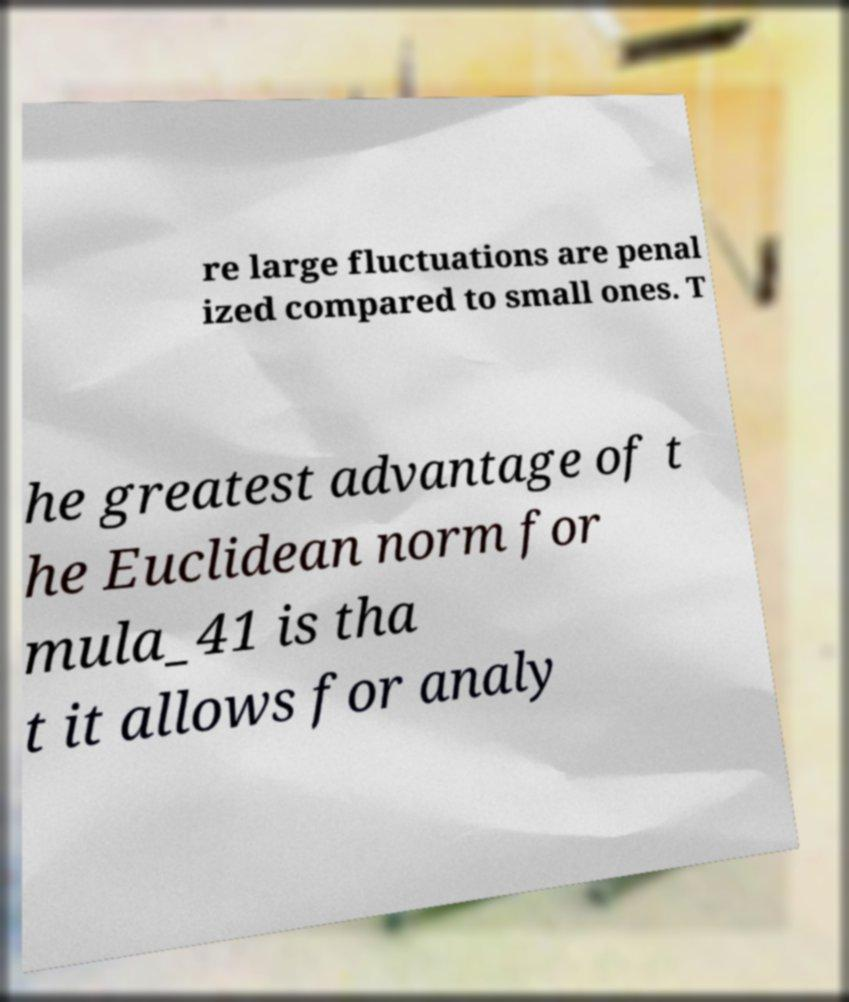Can you read and provide the text displayed in the image?This photo seems to have some interesting text. Can you extract and type it out for me? re large fluctuations are penal ized compared to small ones. T he greatest advantage of t he Euclidean norm for mula_41 is tha t it allows for analy 